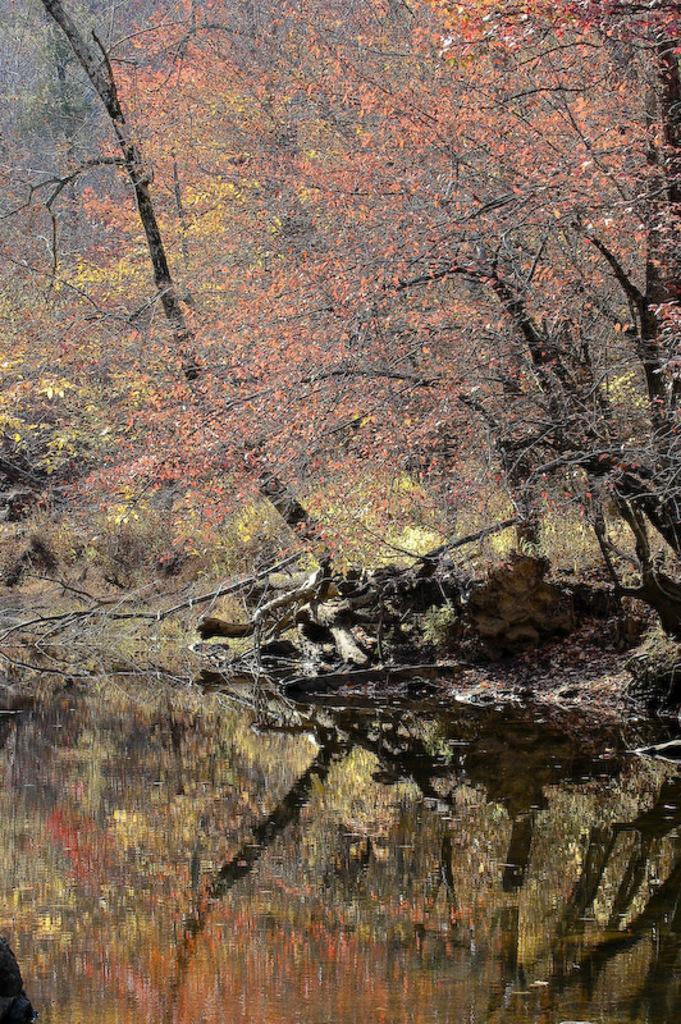Describe this image in one or two sentences. In this picture we can see water and few trees. 